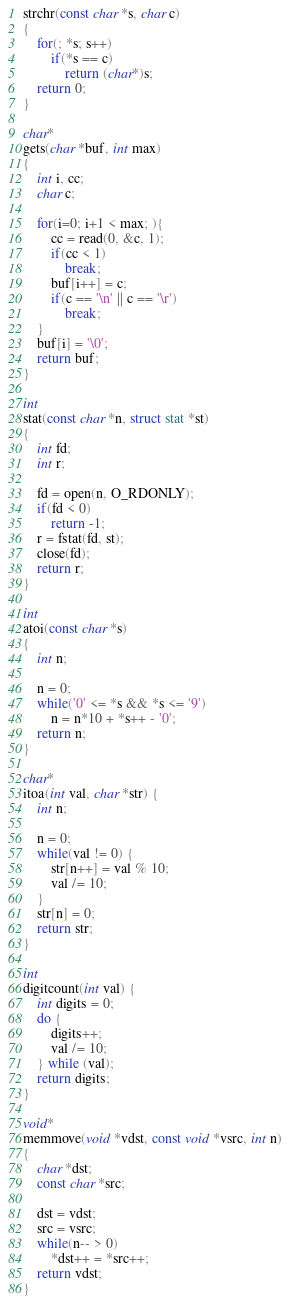Convert code to text. <code><loc_0><loc_0><loc_500><loc_500><_C_>strchr(const char *s, char c)
{
	for(; *s; s++)
		if(*s == c)
			return (char*)s;
	return 0;
}

char*
gets(char *buf, int max)
{
	int i, cc;
	char c;

	for(i=0; i+1 < max; ){
		cc = read(0, &c, 1);
		if(cc < 1)
			break;
		buf[i++] = c;
		if(c == '\n' || c == '\r')
			break;
	}
	buf[i] = '\0';
	return buf;
}

int
stat(const char *n, struct stat *st)
{
	int fd;
	int r;

	fd = open(n, O_RDONLY);
	if(fd < 0)
		return -1;
	r = fstat(fd, st);
	close(fd);
	return r;
}

int
atoi(const char *s)
{
	int n;

	n = 0;
	while('0' <= *s && *s <= '9')
		n = n*10 + *s++ - '0';
	return n;
}

char*
itoa(int val, char *str) {
	int n;
	
	n = 0;
	while(val != 0) {
		str[n++] = val % 10;
		val /= 10;
	}
	str[n] = 0;
	return str;
}

int
digitcount(int val) {
	int digits = 0;
	do {
        digits++;
        val /= 10;
    } while (val);
	return digits;
}

void*
memmove(void *vdst, const void *vsrc, int n)
{
	char *dst;
	const char *src;

	dst = vdst;
	src = vsrc;
	while(n-- > 0)
		*dst++ = *src++;
	return vdst;
}
</code> 